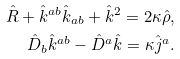Convert formula to latex. <formula><loc_0><loc_0><loc_500><loc_500>\hat { R } + \hat { k } ^ { a b } \hat { k } _ { a b } + \hat { k } ^ { 2 } = 2 \kappa \hat { \rho } , \\ \hat { D } _ { b } \hat { k } ^ { a b } - \hat { D } ^ { a } \hat { k } = \kappa \hat { j } ^ { a } .</formula> 